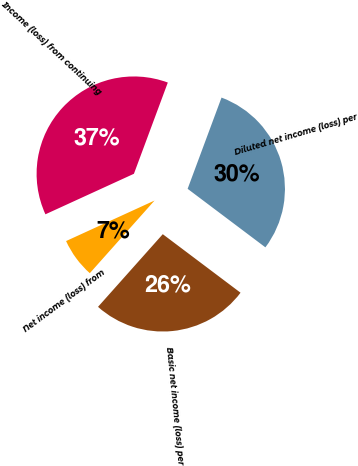Convert chart. <chart><loc_0><loc_0><loc_500><loc_500><pie_chart><fcel>Income (loss) from continuing<fcel>Net income (loss) from<fcel>Basic net income (loss) per<fcel>Diluted net income (loss) per<nl><fcel>37.5%<fcel>6.58%<fcel>26.32%<fcel>29.61%<nl></chart> 